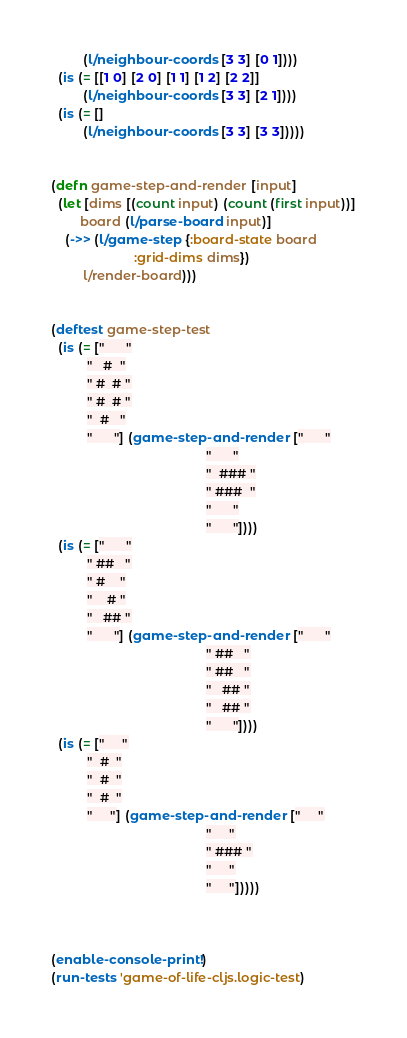Convert code to text. <code><loc_0><loc_0><loc_500><loc_500><_Clojure_>         (l/neighbour-coords [3 3] [0 1])))
  (is (= [[1 0] [2 0] [1 1] [1 2] [2 2]]
         (l/neighbour-coords [3 3] [2 1])))
  (is (= []
         (l/neighbour-coords [3 3] [3 3]))))


(defn game-step-and-render [input]
  (let [dims [(count input) (count (first input))]
        board (l/parse-board input)]
    (->> (l/game-step {:board-state board
                       :grid-dims dims})
         l/render-board)))


(deftest game-step-test
  (is (= ["      "
          "   #  "
          " #  # "
          " #  # "
          "  #   "
          "      "] (game-step-and-render ["      "
                                           "      "
                                           "  ### "
                                           " ###  "
                                           "      "
                                           "      "])))
  (is (= ["      "
          " ##   "
          " #    "
          "    # "
          "   ## "
          "      "] (game-step-and-render ["      "
                                           " ##   "
                                           " ##   "
                                           "   ## "
                                           "   ## "
                                           "      "])))
  (is (= ["     "
          "  #  "
          "  #  "
          "  #  "
          "     "] (game-step-and-render ["     "
                                           "     "
                                           " ### "
                                           "     "
                                           "     "]))))



(enable-console-print!)
(run-tests 'game-of-life-cljs.logic-test)
</code> 